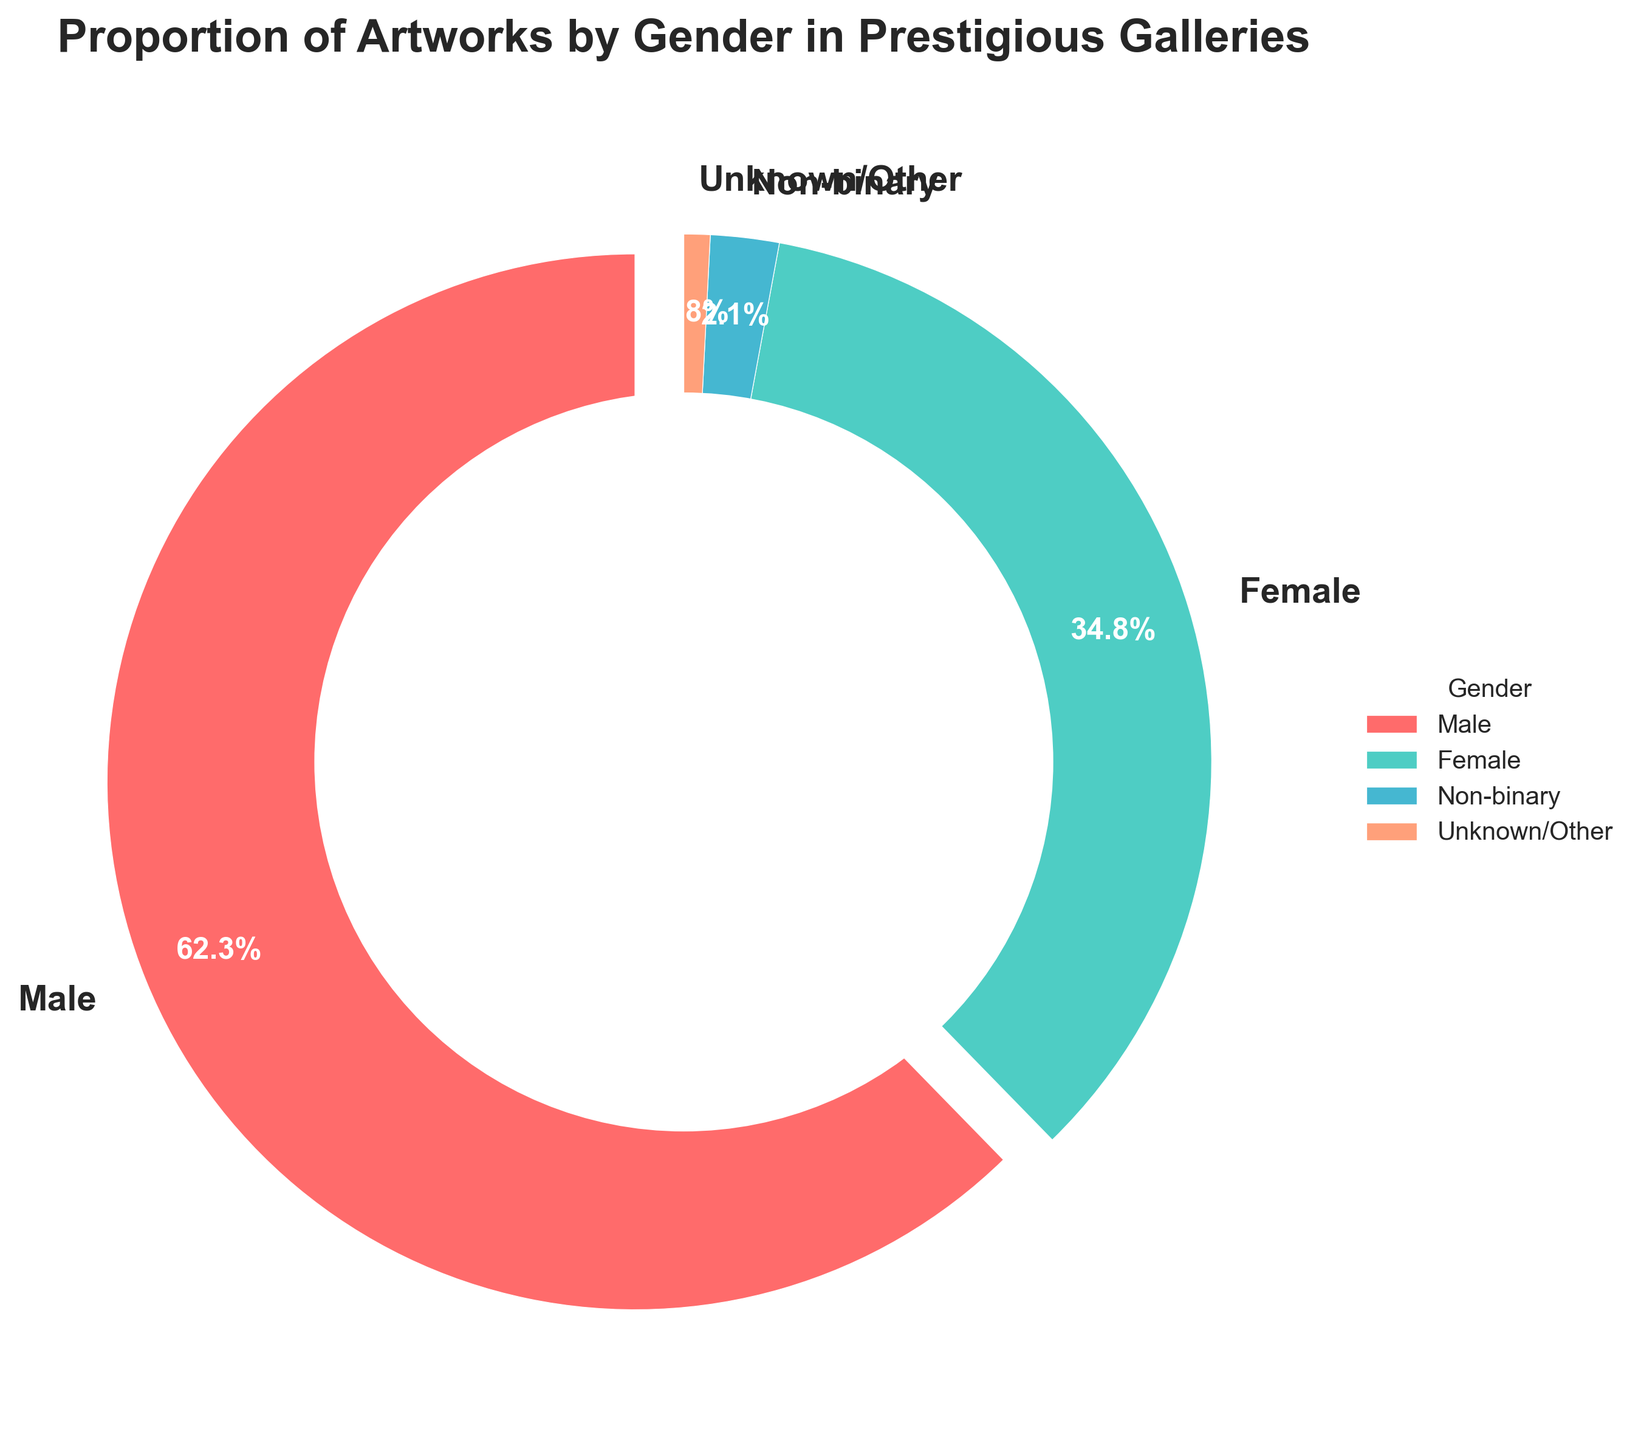What proportion of artworks are by female artists? Refer to the figure and look for the section labeled "Female". The percentage value provided in the pie chart is 34.8%.
Answer: 34.8% How much more is the proportion of artworks by male artists compared to female artists? Find the values for male (62.3%) and female (34.8%) artists and calculate the difference: 62.3% - 34.8% = 27.5%.
Answer: 27.5% What is the combined proportion of artworks by female and non-binary artists? Add the percentages for female (34.8%) and non-binary (2.1%) artists: 34.8% + 2.1% = 36.9%.
Answer: 36.9% Is the proportion of artworks by non-binary artists greater than that by the unknown/other category? Compare the values: non-binary (2.1%) and unknown/other (0.8%). Since 2.1% is greater than 0.8%, the answer is yes.
Answer: Yes Which gender category has the smallest proportion of artworks? Refer to the figure and identify the smallest percentage: Unknown/Other (0.8%).
Answer: Unknown/Other How does the proportion of artworks by male artists compare to the sum of all other categories? Calculate the sum of the proportions for female (34.8%), non-binary (2.1%), and unknown/other (0.8%): 34.8% + 2.1% + 0.8% = 37.7%. Then compare with male (62.3%). Since 37.7% < 62.3%, male artists' proportion is greater.
Answer: Greater What color is used to represent the female artist category in the pie chart? Observe the figure and find the section labeled "Female". The color used for this section is a bluish-green shade.
Answer: Bluish-green Who has the second-largest proportion of artworks after male artists? Refer to the proportions and identify the second largest category, which is female artists at 34.8%.
Answer: Female If a prestigious gallery has 10,000 artworks, around how many would be by non-binary artists? Use the percentage for non-binary artists (2.1%) and multiply by 10,000: 10,000 * 0.021 = 210.
Answer: 210 What's the difference in proportion between non-binary and unknown/other gender categories? Calculate the difference between non-binary (2.1%) and unknown/other (0.8%): 2.1% - 0.8% = 1.3%.
Answer: 1.3% 